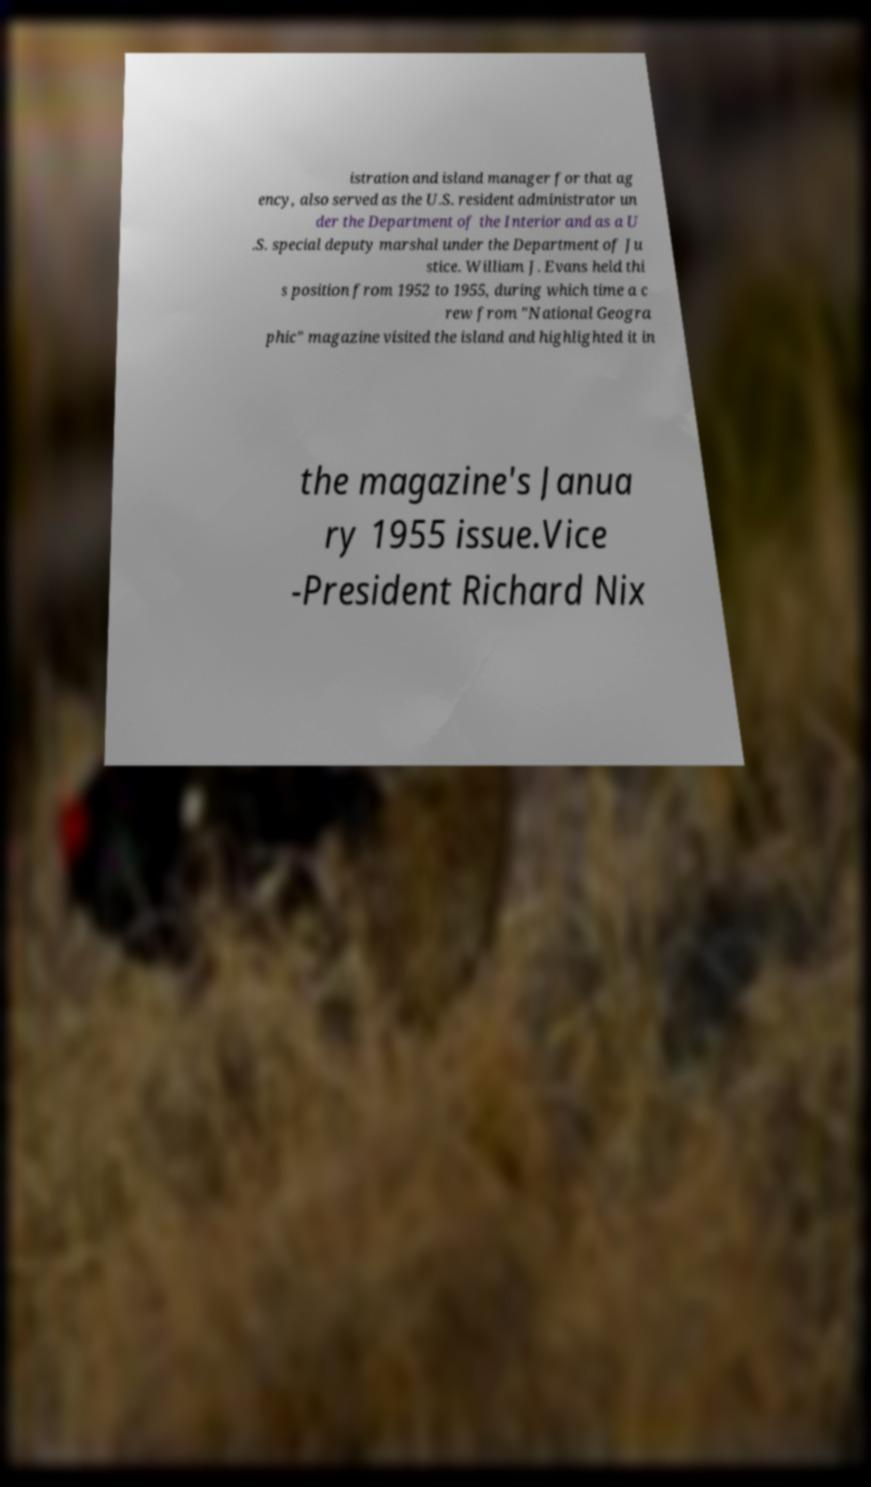Please read and relay the text visible in this image. What does it say? istration and island manager for that ag ency, also served as the U.S. resident administrator un der the Department of the Interior and as a U .S. special deputy marshal under the Department of Ju stice. William J. Evans held thi s position from 1952 to 1955, during which time a c rew from "National Geogra phic" magazine visited the island and highlighted it in the magazine's Janua ry 1955 issue.Vice -President Richard Nix 